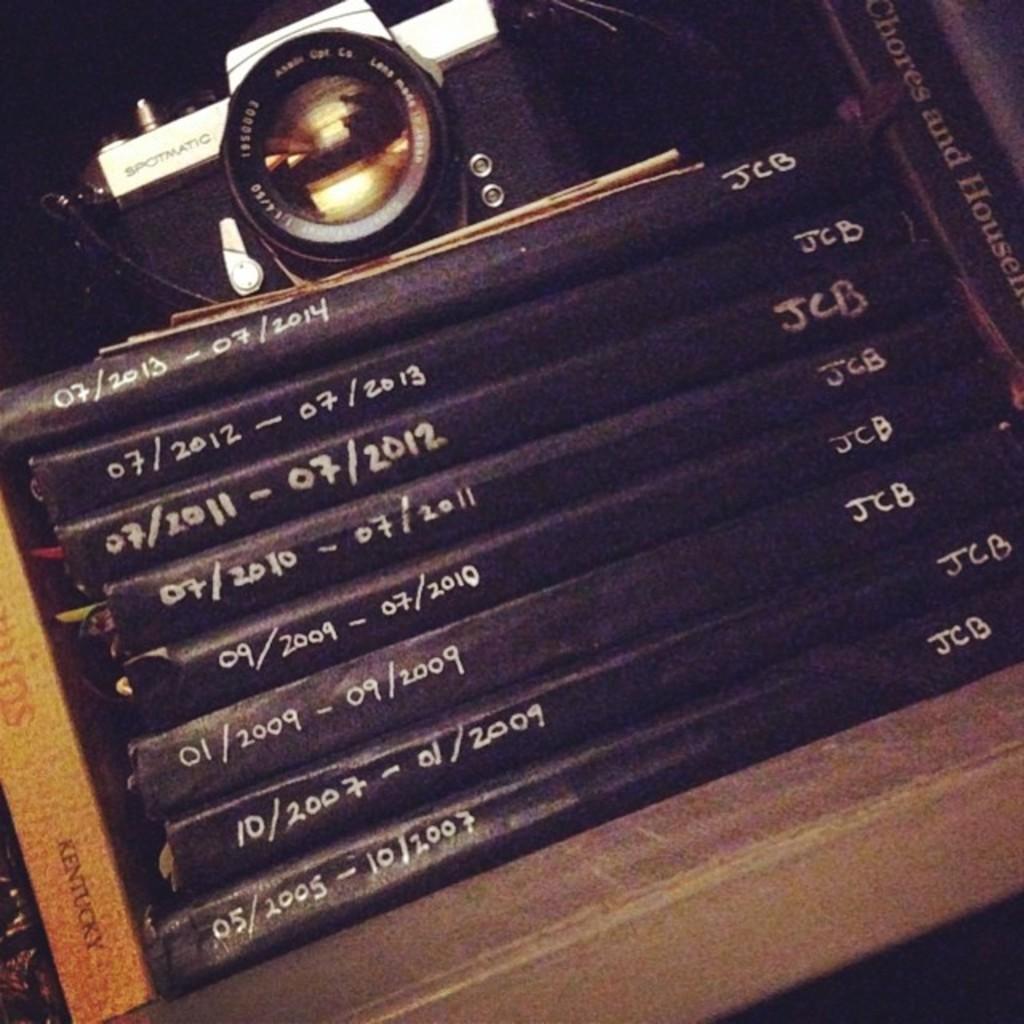What is the dates on top book?
Provide a short and direct response. 07/2013-07/2014. What initials are on the books?
Your response must be concise. Jcb. 